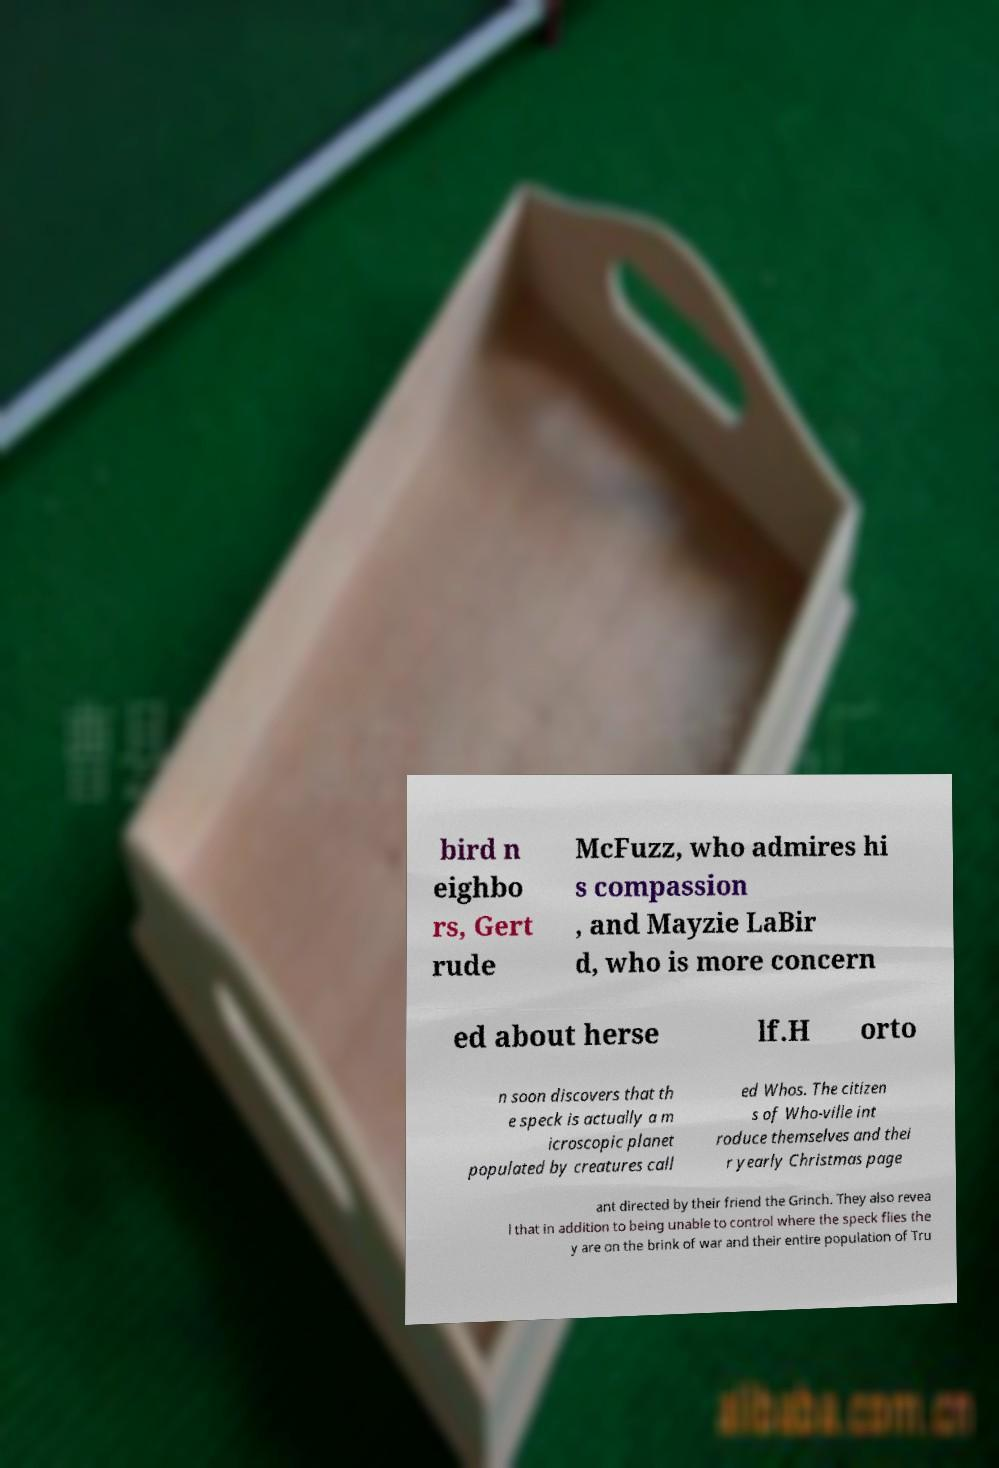Please identify and transcribe the text found in this image. bird n eighbo rs, Gert rude McFuzz, who admires hi s compassion , and Mayzie LaBir d, who is more concern ed about herse lf.H orto n soon discovers that th e speck is actually a m icroscopic planet populated by creatures call ed Whos. The citizen s of Who-ville int roduce themselves and thei r yearly Christmas page ant directed by their friend the Grinch. They also revea l that in addition to being unable to control where the speck flies the y are on the brink of war and their entire population of Tru 